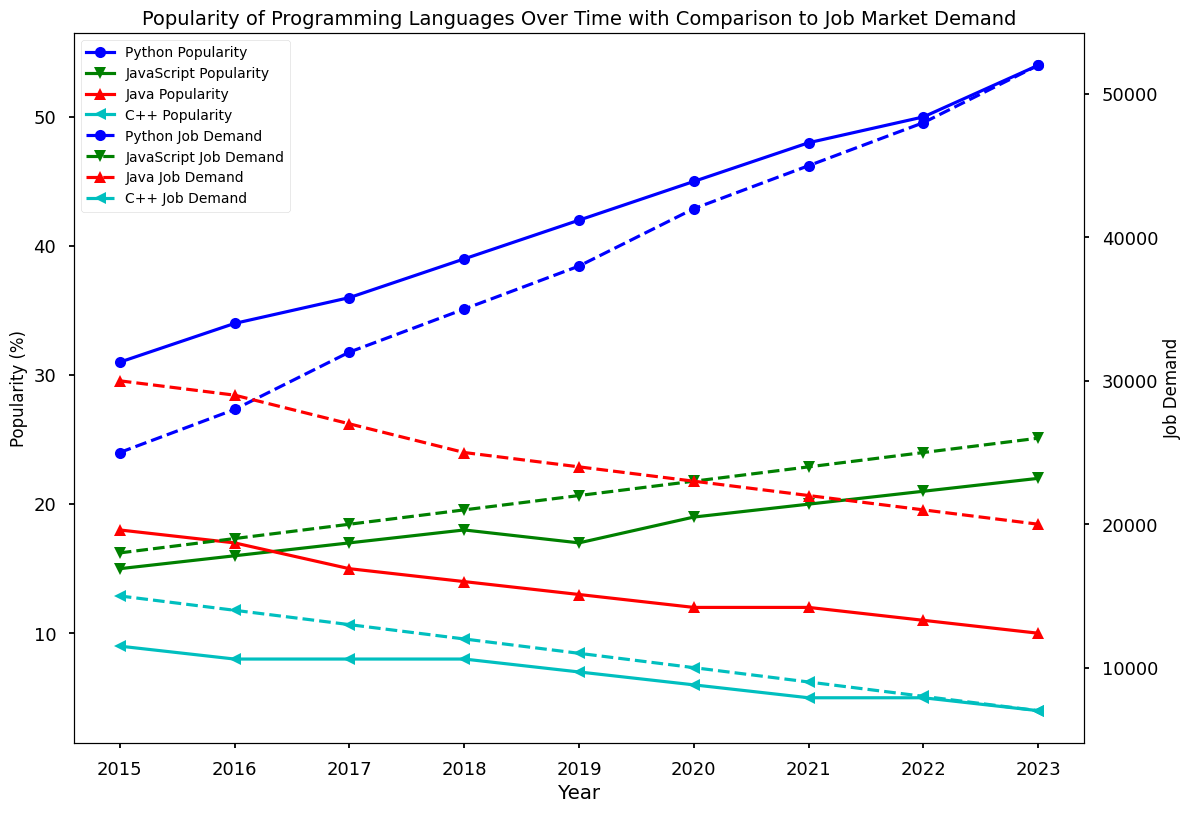What programming language had the highest job demand in 2023? To find the answer, look at the job demand data for each programming language in 2023. Compare the job demand values and identify the highest one.
Answer: Python Which programming language’s popularity decreased over the years? Look at the popularity trend lines for each programming language from 2015 to 2023. Identify the one whose popularity percentage decreased over the observed years.
Answer: C++ How did the job demand for JavaScript change from 2015 to 2023? Look at the job demand values for JavaScript from 2015 to 2023. Compare the values between the two years to see the change.
Answer: Increased from 18,000 to 26,000 What was the difference in popularity between Python and Java in 2020? Evaluate the popularity percentages of Python and Java in the year 2020. Subtract Java's percentage from Python's percentage to find the difference.
Answer: 33 Between which years did Python see the largest increase in popularity, and what was the increase? Observe the yearly changes in Python's popularity. Calculate the difference in percentages for each consecutive year and identify the largest increase.
Answer: 2021 to 2022, 4% Compare the job demands of Java and C++ in 2017. Which had a higher demand, and by how much? Evaluate the job demand values for Java and C++ in the year 2017. Subtract C++'s job demand from Java's to find the difference.
Answer: Java, by 14,000 Which programming language had the lowest popularity in 2019, and what was the percentage? Look at the popularity percentages for each programming language in the year 2019. Identify the one with the lowest value.
Answer: C++, 7% What is the average job demand for Python from 2015 to 2023? Sum the job demand values for Python from 2015 to 2023 and divide by the number of years (9).
Answer: 38333.33 In 2021, how did Java's job demand compare to its popularity? Look at the values for Java's job demand and popularity in 2021. Compare the two values directly.
Answer: Job demand was higher (22,000 vs. 12%) Which year saw the largest decline in C++ job demand, and what was the decline? Observe the job demand values for C++ over the years and note the yearly decreases. Identify the year with the largest decline and calculate the decrease amount.
Answer: 2019 to 2020, 1,000 